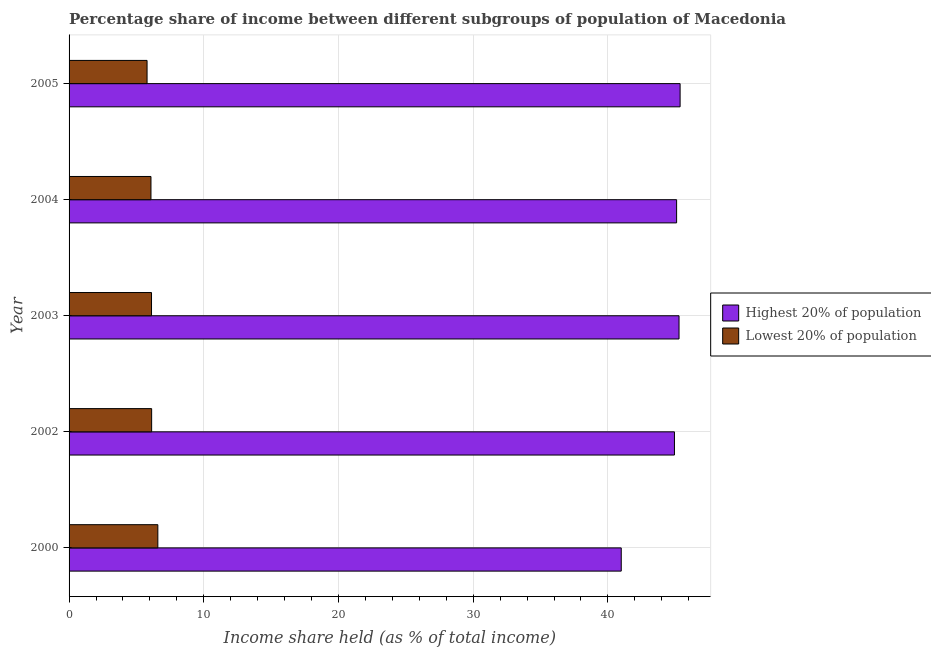How many different coloured bars are there?
Give a very brief answer. 2. How many groups of bars are there?
Make the answer very short. 5. Are the number of bars per tick equal to the number of legend labels?
Keep it short and to the point. Yes. Are the number of bars on each tick of the Y-axis equal?
Offer a terse response. Yes. How many bars are there on the 5th tick from the top?
Offer a very short reply. 2. How many bars are there on the 5th tick from the bottom?
Offer a terse response. 2. What is the label of the 4th group of bars from the top?
Keep it short and to the point. 2002. In how many cases, is the number of bars for a given year not equal to the number of legend labels?
Make the answer very short. 0. What is the income share held by highest 20% of the population in 2003?
Ensure brevity in your answer.  45.28. Across all years, what is the maximum income share held by lowest 20% of the population?
Ensure brevity in your answer.  6.59. Across all years, what is the minimum income share held by lowest 20% of the population?
Make the answer very short. 5.79. In which year was the income share held by lowest 20% of the population maximum?
Make the answer very short. 2000. What is the total income share held by highest 20% of the population in the graph?
Provide a succinct answer. 221.67. What is the difference between the income share held by highest 20% of the population in 2002 and that in 2004?
Provide a succinct answer. -0.16. What is the difference between the income share held by lowest 20% of the population in 2000 and the income share held by highest 20% of the population in 2002?
Your answer should be very brief. -38.35. What is the average income share held by highest 20% of the population per year?
Offer a very short reply. 44.33. In the year 2003, what is the difference between the income share held by lowest 20% of the population and income share held by highest 20% of the population?
Ensure brevity in your answer.  -39.16. In how many years, is the income share held by lowest 20% of the population greater than 32 %?
Your answer should be compact. 0. What is the ratio of the income share held by lowest 20% of the population in 2000 to that in 2003?
Keep it short and to the point. 1.08. Is the income share held by lowest 20% of the population in 2002 less than that in 2005?
Ensure brevity in your answer.  No. What is the difference between the highest and the second highest income share held by lowest 20% of the population?
Offer a very short reply. 0.46. Is the sum of the income share held by lowest 20% of the population in 2002 and 2003 greater than the maximum income share held by highest 20% of the population across all years?
Your answer should be very brief. No. What does the 1st bar from the top in 2002 represents?
Make the answer very short. Lowest 20% of population. What does the 1st bar from the bottom in 2000 represents?
Offer a terse response. Highest 20% of population. Are all the bars in the graph horizontal?
Your response must be concise. Yes. Are the values on the major ticks of X-axis written in scientific E-notation?
Make the answer very short. No. Does the graph contain any zero values?
Provide a succinct answer. No. Does the graph contain grids?
Keep it short and to the point. Yes. How many legend labels are there?
Offer a terse response. 2. What is the title of the graph?
Ensure brevity in your answer.  Percentage share of income between different subgroups of population of Macedonia. Does "Secondary" appear as one of the legend labels in the graph?
Ensure brevity in your answer.  No. What is the label or title of the X-axis?
Your answer should be compact. Income share held (as % of total income). What is the Income share held (as % of total income) of Highest 20% of population in 2000?
Offer a very short reply. 40.99. What is the Income share held (as % of total income) in Lowest 20% of population in 2000?
Ensure brevity in your answer.  6.59. What is the Income share held (as % of total income) of Highest 20% of population in 2002?
Make the answer very short. 44.94. What is the Income share held (as % of total income) of Lowest 20% of population in 2002?
Offer a terse response. 6.13. What is the Income share held (as % of total income) of Highest 20% of population in 2003?
Your answer should be very brief. 45.28. What is the Income share held (as % of total income) of Lowest 20% of population in 2003?
Keep it short and to the point. 6.12. What is the Income share held (as % of total income) of Highest 20% of population in 2004?
Provide a succinct answer. 45.1. What is the Income share held (as % of total income) of Lowest 20% of population in 2004?
Your answer should be compact. 6.08. What is the Income share held (as % of total income) of Highest 20% of population in 2005?
Your response must be concise. 45.36. What is the Income share held (as % of total income) in Lowest 20% of population in 2005?
Your response must be concise. 5.79. Across all years, what is the maximum Income share held (as % of total income) of Highest 20% of population?
Provide a short and direct response. 45.36. Across all years, what is the maximum Income share held (as % of total income) in Lowest 20% of population?
Make the answer very short. 6.59. Across all years, what is the minimum Income share held (as % of total income) of Highest 20% of population?
Keep it short and to the point. 40.99. Across all years, what is the minimum Income share held (as % of total income) of Lowest 20% of population?
Keep it short and to the point. 5.79. What is the total Income share held (as % of total income) of Highest 20% of population in the graph?
Keep it short and to the point. 221.67. What is the total Income share held (as % of total income) in Lowest 20% of population in the graph?
Provide a short and direct response. 30.71. What is the difference between the Income share held (as % of total income) of Highest 20% of population in 2000 and that in 2002?
Keep it short and to the point. -3.95. What is the difference between the Income share held (as % of total income) of Lowest 20% of population in 2000 and that in 2002?
Your answer should be compact. 0.46. What is the difference between the Income share held (as % of total income) in Highest 20% of population in 2000 and that in 2003?
Your answer should be very brief. -4.29. What is the difference between the Income share held (as % of total income) of Lowest 20% of population in 2000 and that in 2003?
Your answer should be compact. 0.47. What is the difference between the Income share held (as % of total income) of Highest 20% of population in 2000 and that in 2004?
Keep it short and to the point. -4.11. What is the difference between the Income share held (as % of total income) in Lowest 20% of population in 2000 and that in 2004?
Make the answer very short. 0.51. What is the difference between the Income share held (as % of total income) in Highest 20% of population in 2000 and that in 2005?
Make the answer very short. -4.37. What is the difference between the Income share held (as % of total income) in Lowest 20% of population in 2000 and that in 2005?
Provide a short and direct response. 0.8. What is the difference between the Income share held (as % of total income) of Highest 20% of population in 2002 and that in 2003?
Provide a succinct answer. -0.34. What is the difference between the Income share held (as % of total income) in Highest 20% of population in 2002 and that in 2004?
Give a very brief answer. -0.16. What is the difference between the Income share held (as % of total income) in Lowest 20% of population in 2002 and that in 2004?
Make the answer very short. 0.05. What is the difference between the Income share held (as % of total income) in Highest 20% of population in 2002 and that in 2005?
Your response must be concise. -0.42. What is the difference between the Income share held (as % of total income) of Lowest 20% of population in 2002 and that in 2005?
Offer a terse response. 0.34. What is the difference between the Income share held (as % of total income) of Highest 20% of population in 2003 and that in 2004?
Your response must be concise. 0.18. What is the difference between the Income share held (as % of total income) in Highest 20% of population in 2003 and that in 2005?
Ensure brevity in your answer.  -0.08. What is the difference between the Income share held (as % of total income) of Lowest 20% of population in 2003 and that in 2005?
Provide a succinct answer. 0.33. What is the difference between the Income share held (as % of total income) of Highest 20% of population in 2004 and that in 2005?
Keep it short and to the point. -0.26. What is the difference between the Income share held (as % of total income) of Lowest 20% of population in 2004 and that in 2005?
Ensure brevity in your answer.  0.29. What is the difference between the Income share held (as % of total income) in Highest 20% of population in 2000 and the Income share held (as % of total income) in Lowest 20% of population in 2002?
Provide a short and direct response. 34.86. What is the difference between the Income share held (as % of total income) in Highest 20% of population in 2000 and the Income share held (as % of total income) in Lowest 20% of population in 2003?
Keep it short and to the point. 34.87. What is the difference between the Income share held (as % of total income) of Highest 20% of population in 2000 and the Income share held (as % of total income) of Lowest 20% of population in 2004?
Your answer should be very brief. 34.91. What is the difference between the Income share held (as % of total income) in Highest 20% of population in 2000 and the Income share held (as % of total income) in Lowest 20% of population in 2005?
Ensure brevity in your answer.  35.2. What is the difference between the Income share held (as % of total income) in Highest 20% of population in 2002 and the Income share held (as % of total income) in Lowest 20% of population in 2003?
Your answer should be compact. 38.82. What is the difference between the Income share held (as % of total income) of Highest 20% of population in 2002 and the Income share held (as % of total income) of Lowest 20% of population in 2004?
Give a very brief answer. 38.86. What is the difference between the Income share held (as % of total income) in Highest 20% of population in 2002 and the Income share held (as % of total income) in Lowest 20% of population in 2005?
Give a very brief answer. 39.15. What is the difference between the Income share held (as % of total income) of Highest 20% of population in 2003 and the Income share held (as % of total income) of Lowest 20% of population in 2004?
Offer a very short reply. 39.2. What is the difference between the Income share held (as % of total income) of Highest 20% of population in 2003 and the Income share held (as % of total income) of Lowest 20% of population in 2005?
Offer a terse response. 39.49. What is the difference between the Income share held (as % of total income) in Highest 20% of population in 2004 and the Income share held (as % of total income) in Lowest 20% of population in 2005?
Offer a terse response. 39.31. What is the average Income share held (as % of total income) of Highest 20% of population per year?
Make the answer very short. 44.33. What is the average Income share held (as % of total income) of Lowest 20% of population per year?
Offer a very short reply. 6.14. In the year 2000, what is the difference between the Income share held (as % of total income) of Highest 20% of population and Income share held (as % of total income) of Lowest 20% of population?
Your answer should be very brief. 34.4. In the year 2002, what is the difference between the Income share held (as % of total income) in Highest 20% of population and Income share held (as % of total income) in Lowest 20% of population?
Give a very brief answer. 38.81. In the year 2003, what is the difference between the Income share held (as % of total income) in Highest 20% of population and Income share held (as % of total income) in Lowest 20% of population?
Your answer should be compact. 39.16. In the year 2004, what is the difference between the Income share held (as % of total income) of Highest 20% of population and Income share held (as % of total income) of Lowest 20% of population?
Ensure brevity in your answer.  39.02. In the year 2005, what is the difference between the Income share held (as % of total income) of Highest 20% of population and Income share held (as % of total income) of Lowest 20% of population?
Give a very brief answer. 39.57. What is the ratio of the Income share held (as % of total income) of Highest 20% of population in 2000 to that in 2002?
Keep it short and to the point. 0.91. What is the ratio of the Income share held (as % of total income) of Lowest 20% of population in 2000 to that in 2002?
Give a very brief answer. 1.07. What is the ratio of the Income share held (as % of total income) of Highest 20% of population in 2000 to that in 2003?
Provide a succinct answer. 0.91. What is the ratio of the Income share held (as % of total income) in Lowest 20% of population in 2000 to that in 2003?
Provide a succinct answer. 1.08. What is the ratio of the Income share held (as % of total income) of Highest 20% of population in 2000 to that in 2004?
Keep it short and to the point. 0.91. What is the ratio of the Income share held (as % of total income) of Lowest 20% of population in 2000 to that in 2004?
Provide a succinct answer. 1.08. What is the ratio of the Income share held (as % of total income) in Highest 20% of population in 2000 to that in 2005?
Your answer should be very brief. 0.9. What is the ratio of the Income share held (as % of total income) of Lowest 20% of population in 2000 to that in 2005?
Make the answer very short. 1.14. What is the ratio of the Income share held (as % of total income) of Highest 20% of population in 2002 to that in 2003?
Your response must be concise. 0.99. What is the ratio of the Income share held (as % of total income) of Highest 20% of population in 2002 to that in 2004?
Your answer should be very brief. 1. What is the ratio of the Income share held (as % of total income) of Lowest 20% of population in 2002 to that in 2004?
Offer a very short reply. 1.01. What is the ratio of the Income share held (as % of total income) in Lowest 20% of population in 2002 to that in 2005?
Make the answer very short. 1.06. What is the ratio of the Income share held (as % of total income) of Highest 20% of population in 2003 to that in 2004?
Make the answer very short. 1. What is the ratio of the Income share held (as % of total income) of Lowest 20% of population in 2003 to that in 2004?
Your answer should be compact. 1.01. What is the ratio of the Income share held (as % of total income) in Lowest 20% of population in 2003 to that in 2005?
Your answer should be compact. 1.06. What is the ratio of the Income share held (as % of total income) of Lowest 20% of population in 2004 to that in 2005?
Make the answer very short. 1.05. What is the difference between the highest and the second highest Income share held (as % of total income) in Lowest 20% of population?
Provide a succinct answer. 0.46. What is the difference between the highest and the lowest Income share held (as % of total income) in Highest 20% of population?
Keep it short and to the point. 4.37. What is the difference between the highest and the lowest Income share held (as % of total income) in Lowest 20% of population?
Provide a short and direct response. 0.8. 